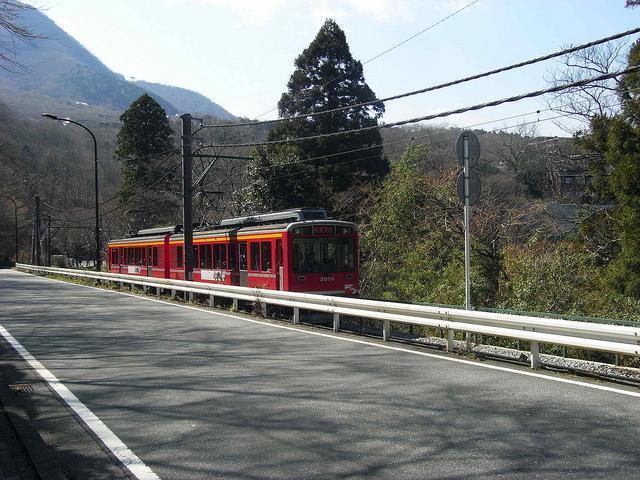How many chairs can you see that are empty?
Give a very brief answer. 0. 